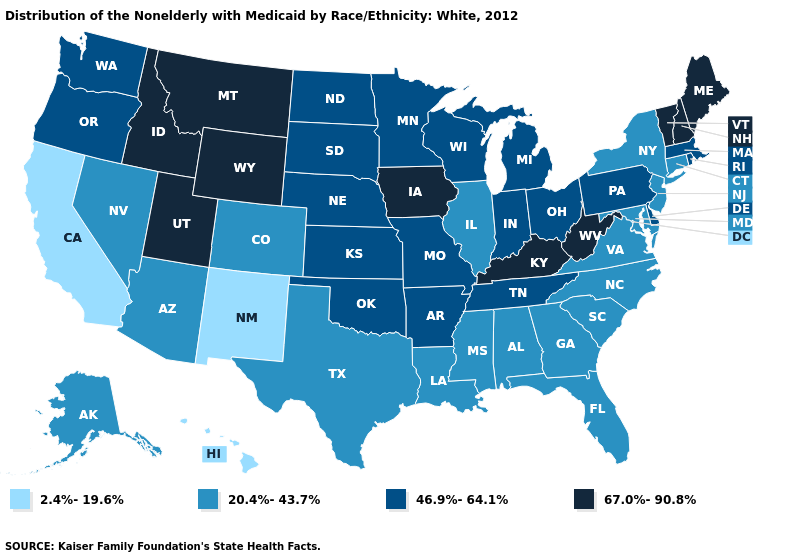Name the states that have a value in the range 2.4%-19.6%?
Write a very short answer. California, Hawaii, New Mexico. What is the value of Washington?
Be succinct. 46.9%-64.1%. Among the states that border New Jersey , does New York have the highest value?
Short answer required. No. Does Connecticut have the same value as Maryland?
Quick response, please. Yes. What is the value of Montana?
Quick response, please. 67.0%-90.8%. Among the states that border Georgia , which have the lowest value?
Short answer required. Alabama, Florida, North Carolina, South Carolina. Name the states that have a value in the range 20.4%-43.7%?
Concise answer only. Alabama, Alaska, Arizona, Colorado, Connecticut, Florida, Georgia, Illinois, Louisiana, Maryland, Mississippi, Nevada, New Jersey, New York, North Carolina, South Carolina, Texas, Virginia. What is the value of New York?
Short answer required. 20.4%-43.7%. Does the first symbol in the legend represent the smallest category?
Answer briefly. Yes. Does the map have missing data?
Write a very short answer. No. Does Minnesota have the same value as Indiana?
Answer briefly. Yes. Does Hawaii have the highest value in the West?
Give a very brief answer. No. What is the value of Wisconsin?
Short answer required. 46.9%-64.1%. Which states hav the highest value in the West?
Quick response, please. Idaho, Montana, Utah, Wyoming. Which states have the lowest value in the MidWest?
Keep it brief. Illinois. 